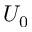<formula> <loc_0><loc_0><loc_500><loc_500>U _ { 0 }</formula> 